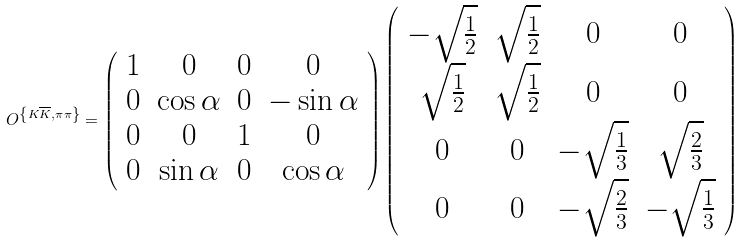Convert formula to latex. <formula><loc_0><loc_0><loc_500><loc_500>O ^ { \left \{ K \overline { K } , \pi \pi \right \} } = \left ( \begin{array} { c c c c } 1 & 0 & 0 & 0 \\ 0 & \cos \alpha & 0 & - \sin \alpha \\ 0 & 0 & 1 & 0 \\ 0 & \sin \alpha & 0 & \cos \alpha \end{array} \right ) \left ( \begin{array} { c c c c } { - } \sqrt { \frac { 1 } { 2 } } & \sqrt { \frac { 1 } { 2 } } & 0 & 0 \\ \sqrt { \frac { 1 } { 2 } } & \sqrt { \frac { 1 } { 2 } } & 0 & 0 \\ 0 & 0 & { - } \sqrt { \frac { 1 } { 3 } } & \sqrt { \frac { 2 } { 3 } } \\ 0 & 0 & { - } \sqrt { \frac { 2 } { 3 } } & { - } \sqrt { \frac { 1 } { 3 } } \end{array} \right )</formula> 